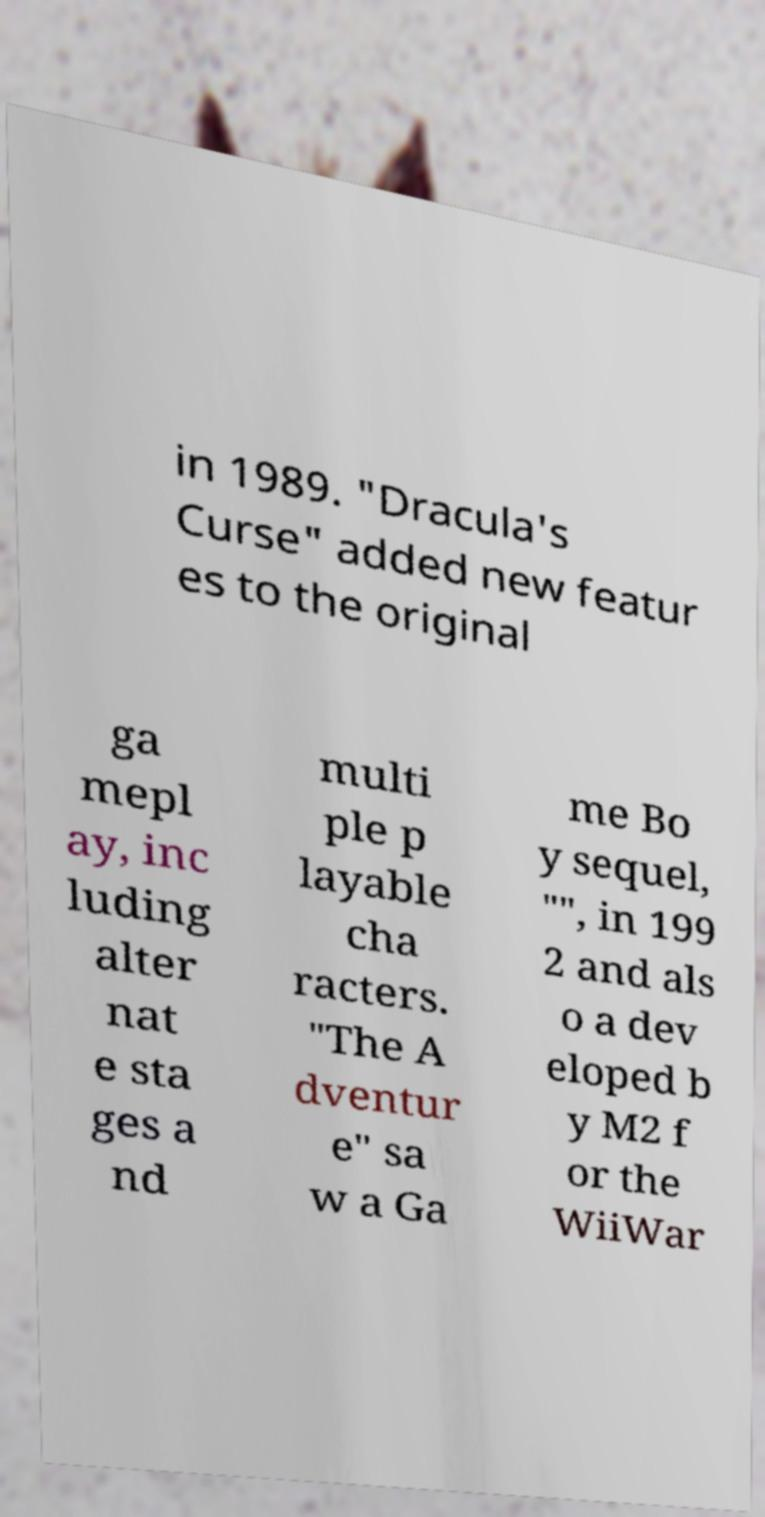Please read and relay the text visible in this image. What does it say? in 1989. "Dracula's Curse" added new featur es to the original ga mepl ay, inc luding alter nat e sta ges a nd multi ple p layable cha racters. "The A dventur e" sa w a Ga me Bo y sequel, "", in 199 2 and als o a dev eloped b y M2 f or the WiiWar 